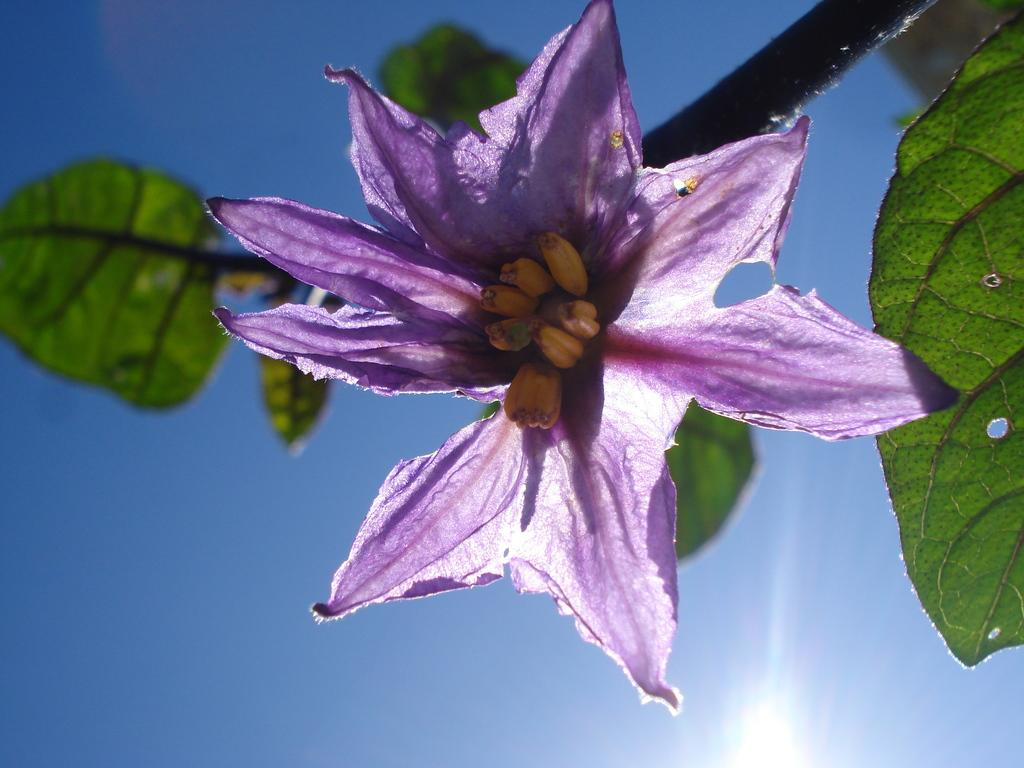What is the main subject of the image? There is a flower in the image. What can be found on the stem of the flower? The flower has leaves on its stem. What is visible in the background of the image? There is the sky visible behind the flower. How many snails can be seen crawling on the leaves of the flower in the image? There are no snails visible in the image; it only features a flower with leaves on its stem and the sky in the background. 